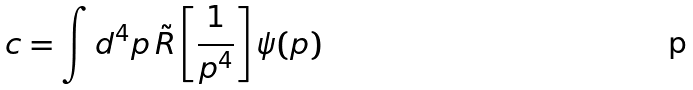<formula> <loc_0><loc_0><loc_500><loc_500>c = \int d ^ { 4 } p \, { \tilde { R } } \left [ { \frac { 1 } { p ^ { 4 } } } \right ] \psi ( p )</formula> 